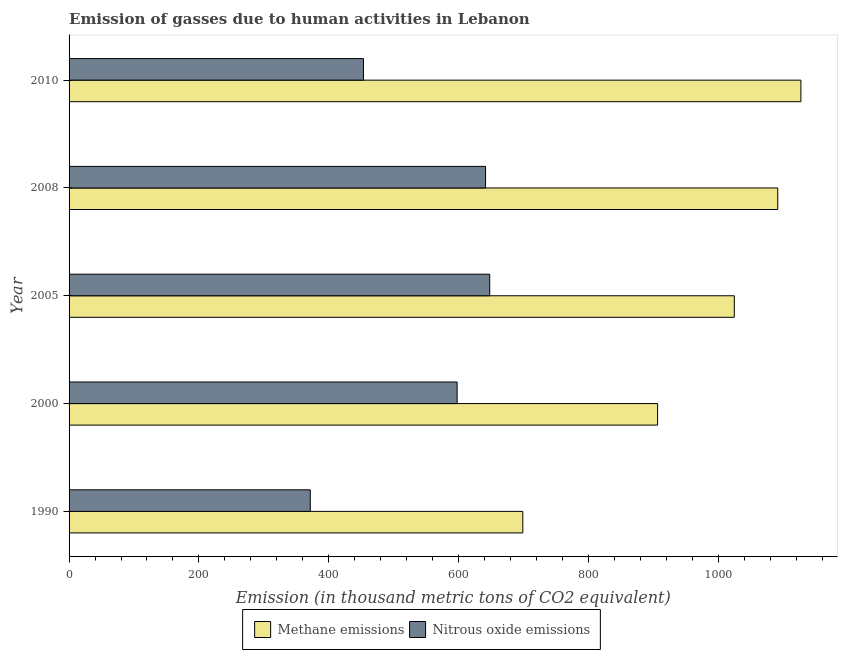How many groups of bars are there?
Provide a succinct answer. 5. Are the number of bars per tick equal to the number of legend labels?
Your answer should be very brief. Yes. How many bars are there on the 1st tick from the top?
Provide a short and direct response. 2. What is the label of the 1st group of bars from the top?
Your answer should be compact. 2010. What is the amount of nitrous oxide emissions in 2000?
Offer a terse response. 597.8. Across all years, what is the maximum amount of nitrous oxide emissions?
Make the answer very short. 648. Across all years, what is the minimum amount of nitrous oxide emissions?
Make the answer very short. 371.6. What is the total amount of nitrous oxide emissions in the graph?
Provide a short and direct response. 2712.5. What is the difference between the amount of methane emissions in 2005 and that in 2010?
Ensure brevity in your answer.  -102.6. What is the difference between the amount of methane emissions in 2000 and the amount of nitrous oxide emissions in 1990?
Provide a succinct answer. 535. What is the average amount of methane emissions per year?
Offer a very short reply. 969.9. In the year 2005, what is the difference between the amount of methane emissions and amount of nitrous oxide emissions?
Your answer should be very brief. 376.8. What is the ratio of the amount of nitrous oxide emissions in 2000 to that in 2005?
Give a very brief answer. 0.92. Is the amount of nitrous oxide emissions in 1990 less than that in 2005?
Your response must be concise. Yes. What is the difference between the highest and the second highest amount of methane emissions?
Provide a succinct answer. 35.7. What is the difference between the highest and the lowest amount of methane emissions?
Your response must be concise. 428.4. What does the 2nd bar from the top in 2010 represents?
Give a very brief answer. Methane emissions. What does the 2nd bar from the bottom in 1990 represents?
Your response must be concise. Nitrous oxide emissions. Are all the bars in the graph horizontal?
Keep it short and to the point. Yes. Are the values on the major ticks of X-axis written in scientific E-notation?
Your response must be concise. No. Does the graph contain any zero values?
Your answer should be very brief. No. Does the graph contain grids?
Provide a short and direct response. No. How many legend labels are there?
Your response must be concise. 2. How are the legend labels stacked?
Give a very brief answer. Horizontal. What is the title of the graph?
Make the answer very short. Emission of gasses due to human activities in Lebanon. What is the label or title of the X-axis?
Offer a very short reply. Emission (in thousand metric tons of CO2 equivalent). What is the label or title of the Y-axis?
Your response must be concise. Year. What is the Emission (in thousand metric tons of CO2 equivalent) in Methane emissions in 1990?
Make the answer very short. 699. What is the Emission (in thousand metric tons of CO2 equivalent) in Nitrous oxide emissions in 1990?
Offer a very short reply. 371.6. What is the Emission (in thousand metric tons of CO2 equivalent) of Methane emissions in 2000?
Your response must be concise. 906.6. What is the Emission (in thousand metric tons of CO2 equivalent) in Nitrous oxide emissions in 2000?
Your answer should be very brief. 597.8. What is the Emission (in thousand metric tons of CO2 equivalent) in Methane emissions in 2005?
Your response must be concise. 1024.8. What is the Emission (in thousand metric tons of CO2 equivalent) of Nitrous oxide emissions in 2005?
Keep it short and to the point. 648. What is the Emission (in thousand metric tons of CO2 equivalent) of Methane emissions in 2008?
Offer a very short reply. 1091.7. What is the Emission (in thousand metric tons of CO2 equivalent) in Nitrous oxide emissions in 2008?
Provide a short and direct response. 641.6. What is the Emission (in thousand metric tons of CO2 equivalent) of Methane emissions in 2010?
Offer a very short reply. 1127.4. What is the Emission (in thousand metric tons of CO2 equivalent) of Nitrous oxide emissions in 2010?
Give a very brief answer. 453.5. Across all years, what is the maximum Emission (in thousand metric tons of CO2 equivalent) in Methane emissions?
Offer a very short reply. 1127.4. Across all years, what is the maximum Emission (in thousand metric tons of CO2 equivalent) in Nitrous oxide emissions?
Provide a succinct answer. 648. Across all years, what is the minimum Emission (in thousand metric tons of CO2 equivalent) of Methane emissions?
Give a very brief answer. 699. Across all years, what is the minimum Emission (in thousand metric tons of CO2 equivalent) in Nitrous oxide emissions?
Make the answer very short. 371.6. What is the total Emission (in thousand metric tons of CO2 equivalent) of Methane emissions in the graph?
Keep it short and to the point. 4849.5. What is the total Emission (in thousand metric tons of CO2 equivalent) in Nitrous oxide emissions in the graph?
Keep it short and to the point. 2712.5. What is the difference between the Emission (in thousand metric tons of CO2 equivalent) in Methane emissions in 1990 and that in 2000?
Provide a succinct answer. -207.6. What is the difference between the Emission (in thousand metric tons of CO2 equivalent) in Nitrous oxide emissions in 1990 and that in 2000?
Your response must be concise. -226.2. What is the difference between the Emission (in thousand metric tons of CO2 equivalent) in Methane emissions in 1990 and that in 2005?
Offer a terse response. -325.8. What is the difference between the Emission (in thousand metric tons of CO2 equivalent) in Nitrous oxide emissions in 1990 and that in 2005?
Your response must be concise. -276.4. What is the difference between the Emission (in thousand metric tons of CO2 equivalent) of Methane emissions in 1990 and that in 2008?
Make the answer very short. -392.7. What is the difference between the Emission (in thousand metric tons of CO2 equivalent) of Nitrous oxide emissions in 1990 and that in 2008?
Your response must be concise. -270. What is the difference between the Emission (in thousand metric tons of CO2 equivalent) in Methane emissions in 1990 and that in 2010?
Give a very brief answer. -428.4. What is the difference between the Emission (in thousand metric tons of CO2 equivalent) of Nitrous oxide emissions in 1990 and that in 2010?
Make the answer very short. -81.9. What is the difference between the Emission (in thousand metric tons of CO2 equivalent) of Methane emissions in 2000 and that in 2005?
Offer a very short reply. -118.2. What is the difference between the Emission (in thousand metric tons of CO2 equivalent) in Nitrous oxide emissions in 2000 and that in 2005?
Provide a short and direct response. -50.2. What is the difference between the Emission (in thousand metric tons of CO2 equivalent) of Methane emissions in 2000 and that in 2008?
Offer a terse response. -185.1. What is the difference between the Emission (in thousand metric tons of CO2 equivalent) in Nitrous oxide emissions in 2000 and that in 2008?
Offer a very short reply. -43.8. What is the difference between the Emission (in thousand metric tons of CO2 equivalent) of Methane emissions in 2000 and that in 2010?
Ensure brevity in your answer.  -220.8. What is the difference between the Emission (in thousand metric tons of CO2 equivalent) in Nitrous oxide emissions in 2000 and that in 2010?
Give a very brief answer. 144.3. What is the difference between the Emission (in thousand metric tons of CO2 equivalent) of Methane emissions in 2005 and that in 2008?
Your response must be concise. -66.9. What is the difference between the Emission (in thousand metric tons of CO2 equivalent) of Nitrous oxide emissions in 2005 and that in 2008?
Provide a short and direct response. 6.4. What is the difference between the Emission (in thousand metric tons of CO2 equivalent) of Methane emissions in 2005 and that in 2010?
Your response must be concise. -102.6. What is the difference between the Emission (in thousand metric tons of CO2 equivalent) of Nitrous oxide emissions in 2005 and that in 2010?
Offer a very short reply. 194.5. What is the difference between the Emission (in thousand metric tons of CO2 equivalent) of Methane emissions in 2008 and that in 2010?
Your answer should be compact. -35.7. What is the difference between the Emission (in thousand metric tons of CO2 equivalent) of Nitrous oxide emissions in 2008 and that in 2010?
Provide a short and direct response. 188.1. What is the difference between the Emission (in thousand metric tons of CO2 equivalent) of Methane emissions in 1990 and the Emission (in thousand metric tons of CO2 equivalent) of Nitrous oxide emissions in 2000?
Provide a succinct answer. 101.2. What is the difference between the Emission (in thousand metric tons of CO2 equivalent) of Methane emissions in 1990 and the Emission (in thousand metric tons of CO2 equivalent) of Nitrous oxide emissions in 2008?
Your response must be concise. 57.4. What is the difference between the Emission (in thousand metric tons of CO2 equivalent) in Methane emissions in 1990 and the Emission (in thousand metric tons of CO2 equivalent) in Nitrous oxide emissions in 2010?
Ensure brevity in your answer.  245.5. What is the difference between the Emission (in thousand metric tons of CO2 equivalent) in Methane emissions in 2000 and the Emission (in thousand metric tons of CO2 equivalent) in Nitrous oxide emissions in 2005?
Your answer should be compact. 258.6. What is the difference between the Emission (in thousand metric tons of CO2 equivalent) in Methane emissions in 2000 and the Emission (in thousand metric tons of CO2 equivalent) in Nitrous oxide emissions in 2008?
Your answer should be very brief. 265. What is the difference between the Emission (in thousand metric tons of CO2 equivalent) in Methane emissions in 2000 and the Emission (in thousand metric tons of CO2 equivalent) in Nitrous oxide emissions in 2010?
Your answer should be very brief. 453.1. What is the difference between the Emission (in thousand metric tons of CO2 equivalent) in Methane emissions in 2005 and the Emission (in thousand metric tons of CO2 equivalent) in Nitrous oxide emissions in 2008?
Ensure brevity in your answer.  383.2. What is the difference between the Emission (in thousand metric tons of CO2 equivalent) in Methane emissions in 2005 and the Emission (in thousand metric tons of CO2 equivalent) in Nitrous oxide emissions in 2010?
Offer a very short reply. 571.3. What is the difference between the Emission (in thousand metric tons of CO2 equivalent) of Methane emissions in 2008 and the Emission (in thousand metric tons of CO2 equivalent) of Nitrous oxide emissions in 2010?
Provide a succinct answer. 638.2. What is the average Emission (in thousand metric tons of CO2 equivalent) in Methane emissions per year?
Ensure brevity in your answer.  969.9. What is the average Emission (in thousand metric tons of CO2 equivalent) in Nitrous oxide emissions per year?
Keep it short and to the point. 542.5. In the year 1990, what is the difference between the Emission (in thousand metric tons of CO2 equivalent) in Methane emissions and Emission (in thousand metric tons of CO2 equivalent) in Nitrous oxide emissions?
Provide a succinct answer. 327.4. In the year 2000, what is the difference between the Emission (in thousand metric tons of CO2 equivalent) in Methane emissions and Emission (in thousand metric tons of CO2 equivalent) in Nitrous oxide emissions?
Keep it short and to the point. 308.8. In the year 2005, what is the difference between the Emission (in thousand metric tons of CO2 equivalent) in Methane emissions and Emission (in thousand metric tons of CO2 equivalent) in Nitrous oxide emissions?
Make the answer very short. 376.8. In the year 2008, what is the difference between the Emission (in thousand metric tons of CO2 equivalent) in Methane emissions and Emission (in thousand metric tons of CO2 equivalent) in Nitrous oxide emissions?
Keep it short and to the point. 450.1. In the year 2010, what is the difference between the Emission (in thousand metric tons of CO2 equivalent) in Methane emissions and Emission (in thousand metric tons of CO2 equivalent) in Nitrous oxide emissions?
Ensure brevity in your answer.  673.9. What is the ratio of the Emission (in thousand metric tons of CO2 equivalent) of Methane emissions in 1990 to that in 2000?
Your answer should be compact. 0.77. What is the ratio of the Emission (in thousand metric tons of CO2 equivalent) in Nitrous oxide emissions in 1990 to that in 2000?
Give a very brief answer. 0.62. What is the ratio of the Emission (in thousand metric tons of CO2 equivalent) of Methane emissions in 1990 to that in 2005?
Give a very brief answer. 0.68. What is the ratio of the Emission (in thousand metric tons of CO2 equivalent) in Nitrous oxide emissions in 1990 to that in 2005?
Offer a very short reply. 0.57. What is the ratio of the Emission (in thousand metric tons of CO2 equivalent) of Methane emissions in 1990 to that in 2008?
Ensure brevity in your answer.  0.64. What is the ratio of the Emission (in thousand metric tons of CO2 equivalent) of Nitrous oxide emissions in 1990 to that in 2008?
Keep it short and to the point. 0.58. What is the ratio of the Emission (in thousand metric tons of CO2 equivalent) in Methane emissions in 1990 to that in 2010?
Make the answer very short. 0.62. What is the ratio of the Emission (in thousand metric tons of CO2 equivalent) in Nitrous oxide emissions in 1990 to that in 2010?
Keep it short and to the point. 0.82. What is the ratio of the Emission (in thousand metric tons of CO2 equivalent) of Methane emissions in 2000 to that in 2005?
Offer a very short reply. 0.88. What is the ratio of the Emission (in thousand metric tons of CO2 equivalent) in Nitrous oxide emissions in 2000 to that in 2005?
Keep it short and to the point. 0.92. What is the ratio of the Emission (in thousand metric tons of CO2 equivalent) in Methane emissions in 2000 to that in 2008?
Keep it short and to the point. 0.83. What is the ratio of the Emission (in thousand metric tons of CO2 equivalent) of Nitrous oxide emissions in 2000 to that in 2008?
Provide a short and direct response. 0.93. What is the ratio of the Emission (in thousand metric tons of CO2 equivalent) in Methane emissions in 2000 to that in 2010?
Give a very brief answer. 0.8. What is the ratio of the Emission (in thousand metric tons of CO2 equivalent) in Nitrous oxide emissions in 2000 to that in 2010?
Offer a very short reply. 1.32. What is the ratio of the Emission (in thousand metric tons of CO2 equivalent) in Methane emissions in 2005 to that in 2008?
Offer a terse response. 0.94. What is the ratio of the Emission (in thousand metric tons of CO2 equivalent) of Methane emissions in 2005 to that in 2010?
Ensure brevity in your answer.  0.91. What is the ratio of the Emission (in thousand metric tons of CO2 equivalent) in Nitrous oxide emissions in 2005 to that in 2010?
Offer a terse response. 1.43. What is the ratio of the Emission (in thousand metric tons of CO2 equivalent) in Methane emissions in 2008 to that in 2010?
Your answer should be compact. 0.97. What is the ratio of the Emission (in thousand metric tons of CO2 equivalent) of Nitrous oxide emissions in 2008 to that in 2010?
Give a very brief answer. 1.41. What is the difference between the highest and the second highest Emission (in thousand metric tons of CO2 equivalent) in Methane emissions?
Your answer should be compact. 35.7. What is the difference between the highest and the second highest Emission (in thousand metric tons of CO2 equivalent) in Nitrous oxide emissions?
Give a very brief answer. 6.4. What is the difference between the highest and the lowest Emission (in thousand metric tons of CO2 equivalent) in Methane emissions?
Give a very brief answer. 428.4. What is the difference between the highest and the lowest Emission (in thousand metric tons of CO2 equivalent) in Nitrous oxide emissions?
Make the answer very short. 276.4. 